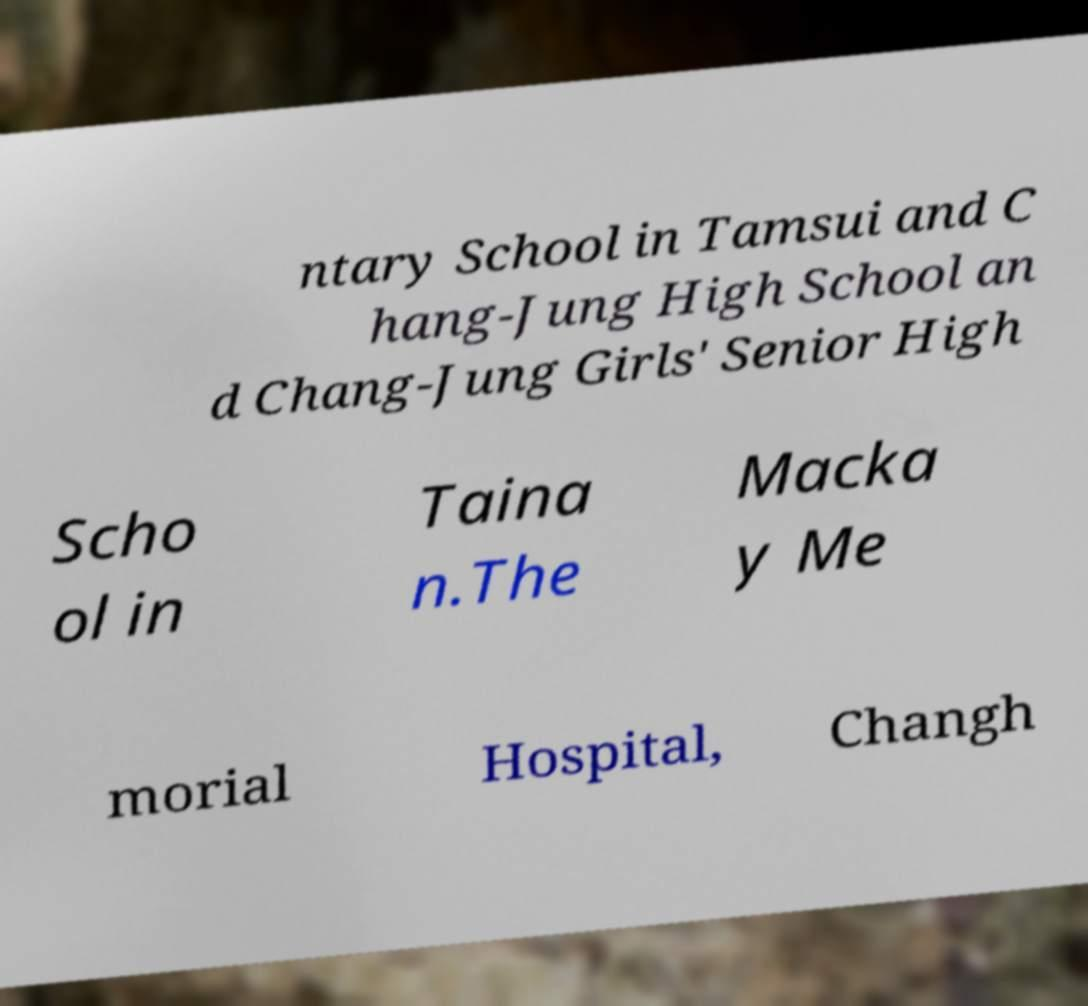Could you extract and type out the text from this image? ntary School in Tamsui and C hang-Jung High School an d Chang-Jung Girls' Senior High Scho ol in Taina n.The Macka y Me morial Hospital, Changh 